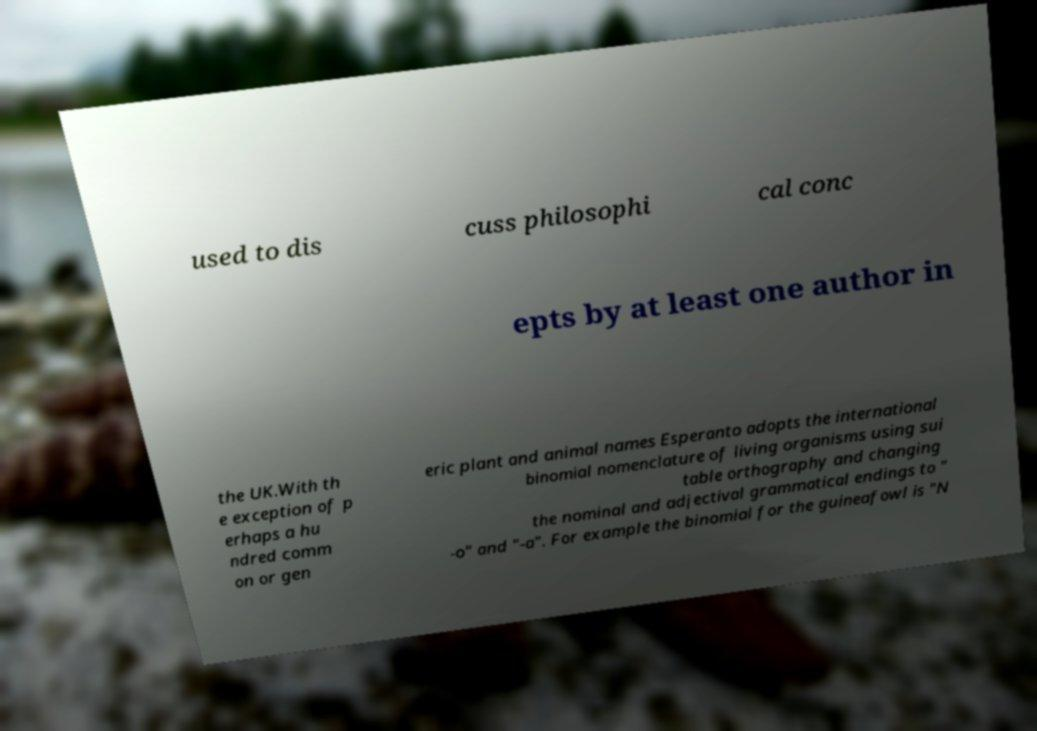Can you read and provide the text displayed in the image?This photo seems to have some interesting text. Can you extract and type it out for me? used to dis cuss philosophi cal conc epts by at least one author in the UK.With th e exception of p erhaps a hu ndred comm on or gen eric plant and animal names Esperanto adopts the international binomial nomenclature of living organisms using sui table orthography and changing the nominal and adjectival grammatical endings to " -o" and "-a". For example the binomial for the guineafowl is "N 